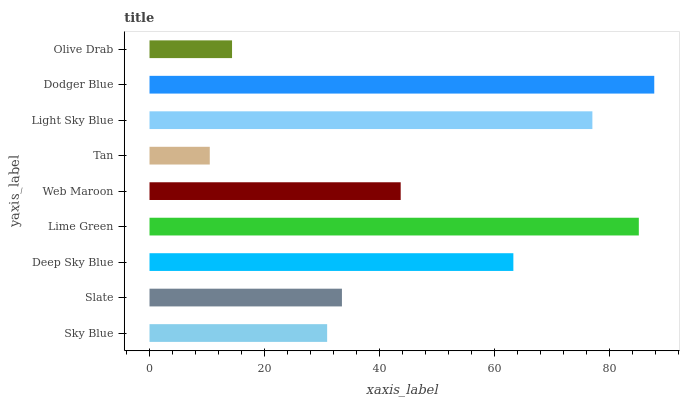Is Tan the minimum?
Answer yes or no. Yes. Is Dodger Blue the maximum?
Answer yes or no. Yes. Is Slate the minimum?
Answer yes or no. No. Is Slate the maximum?
Answer yes or no. No. Is Slate greater than Sky Blue?
Answer yes or no. Yes. Is Sky Blue less than Slate?
Answer yes or no. Yes. Is Sky Blue greater than Slate?
Answer yes or no. No. Is Slate less than Sky Blue?
Answer yes or no. No. Is Web Maroon the high median?
Answer yes or no. Yes. Is Web Maroon the low median?
Answer yes or no. Yes. Is Slate the high median?
Answer yes or no. No. Is Olive Drab the low median?
Answer yes or no. No. 